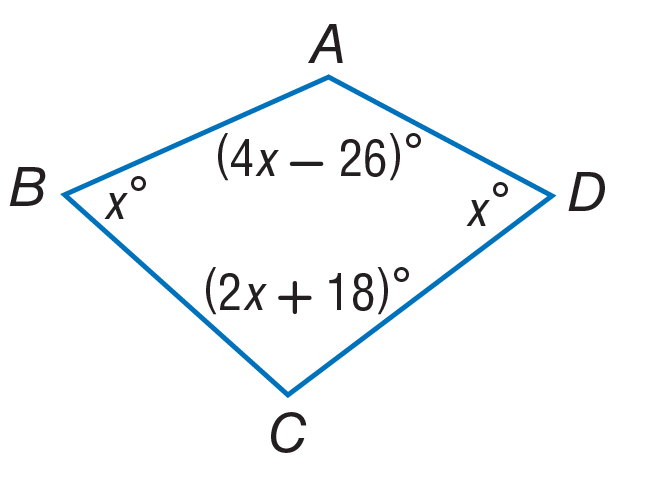Answer the mathemtical geometry problem and directly provide the correct option letter.
Question: Find the measure of \angle C.
Choices: A: 56 B: 110 C: 112 D: 130 B 